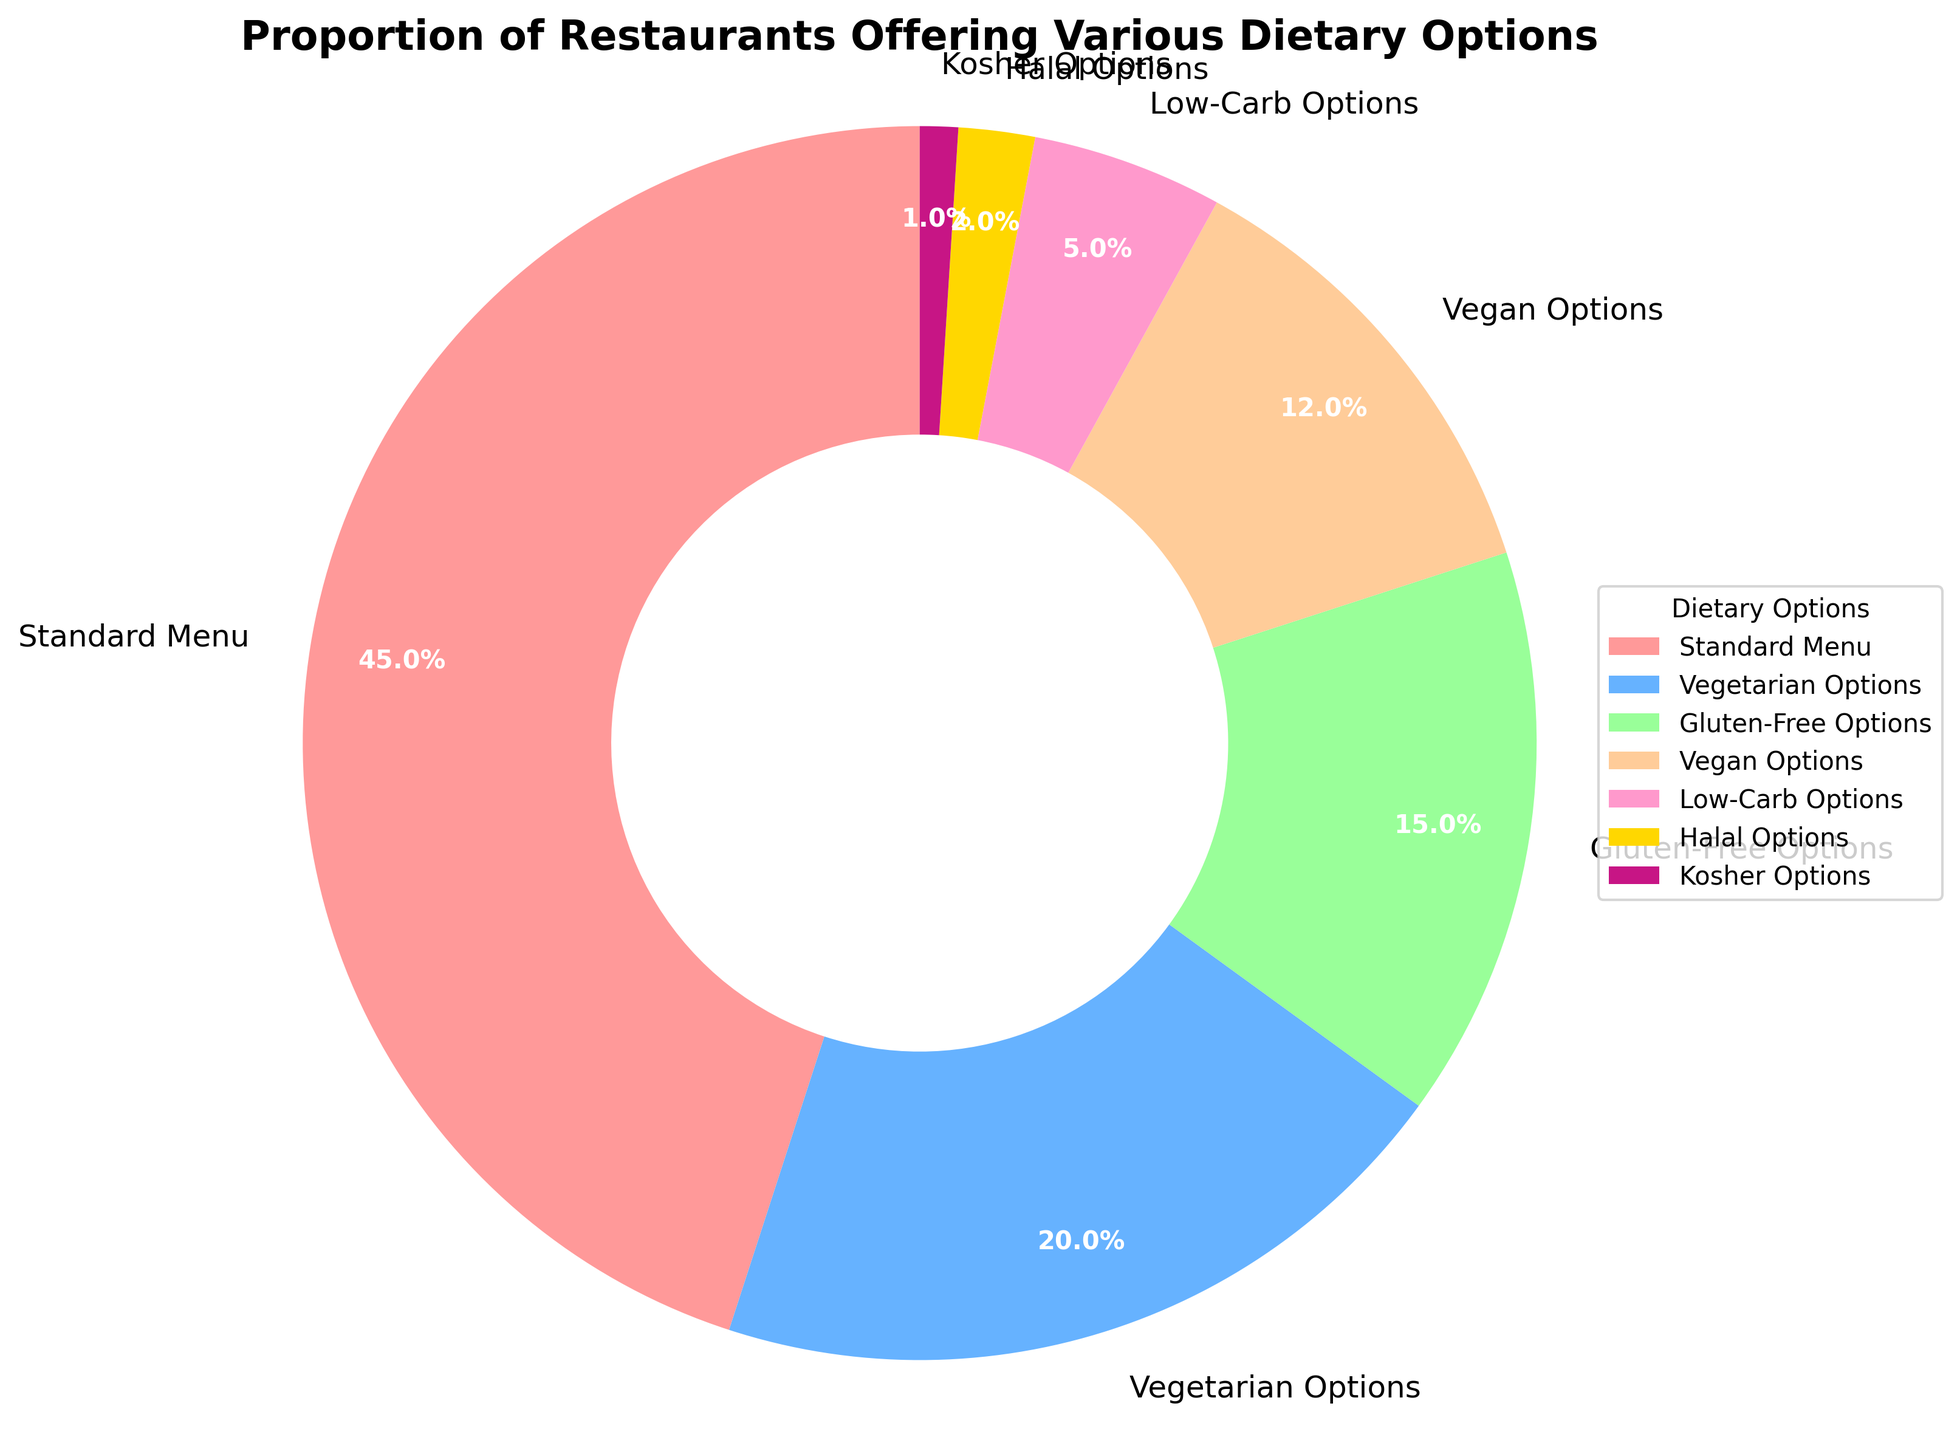What proportion of restaurants offer vegan or gluten-free options combined? To find the combined proportion, sum the percentages of restaurants offering vegan options (12%) and gluten-free options (15%). Thus, 12% + 15% = 27%.
Answer: 27% Which dietary option is offered by the largest proportion of restaurants? The pie chart shows that 'Standard Menu' has the largest section with 45%. Comparing this to other options, it's clear that 'Standard Menu' is the largest.
Answer: Standard Menu Which dietary option has a smaller proportion than low-carb options but larger than halal options? Low-carb options are represented with 5% and halal options with 2%. The dietary option that fits between these two values is Kosher, which has 1%.
Answer: Kosher How much larger is the proportion of restaurants offering vegetarian options compared to those offering low-carb options? Vegetarian options are at 20%, and low-carb options are at 5%. The difference is calculated as 20% - 5% = 15%.
Answer: 15% What two dietary options combined are offered by less than 10% of restaurants? From the chart, Kosher (1%) and Halal (2%) combined are less than 10%. Summing these gives 1% + 2% = 3%.
Answer: Kosher and Halal Rank the dietary options from most to least offered. By comparing the percentages, the ranking from most to least is: Standard Menu (45%), Vegetarian Options (20%), Gluten-Free Options (15%), Vegan Options (12%), Low-Carb Options (5%), Halal Options (2%), Kosher Options (1%).
Answer: Standard Menu, Vegetarian Options, Gluten-Free Options, Vegan Options, Low-Carb Options, Halal Options, Kosher Options Approximately what fraction of restaurants offer some form of alternative dietary options (excluding standard menu)? Summing the proportions of all options except 'Standard Menu' (45%) gives: 20% + 15% + 12% + 5% + 2% + 1% = 55%. Thus, approximately 55% of restaurants offer some form of alternative dietary options.
Answer: 55% What is the difference in the proportion of restaurants offering vegan options compared to those offering gluten-free options? Gluten-free options are shown at 15%, and vegan options at 12%. The difference is 15% - 12% = 3%.
Answer: 3% Identify the dietary option represented by light blue color and its percentage. Visual inspection of the chart shows that the light blue color represents Vegetarian Options, which is 20%.
Answer: Vegetarian Options, 20% Which dietary options together account for more than half of the restaurants? Adding 'Standard Menu' (45%) and 'Vegetarian Options' (20%) gives 45% + 20% = 65%, which is more than half. No other combination surpasses half without 'Standard Menu'.
Answer: Standard Menu and Vegetarian Options 